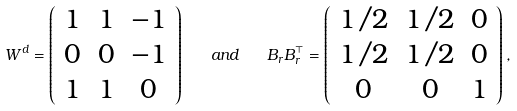<formula> <loc_0><loc_0><loc_500><loc_500>W ^ { d } = \left ( \begin{array} { c c c } 1 & 1 & - 1 \\ 0 & 0 & - 1 \\ 1 & 1 & 0 \end{array} \right ) \quad a n d \quad B _ { r } B _ { r } ^ { \top } = \left ( \begin{array} { c c c } 1 / 2 & 1 / 2 & 0 \\ 1 / 2 & 1 / 2 & 0 \\ 0 & 0 & 1 \end{array} \right ) ,</formula> 